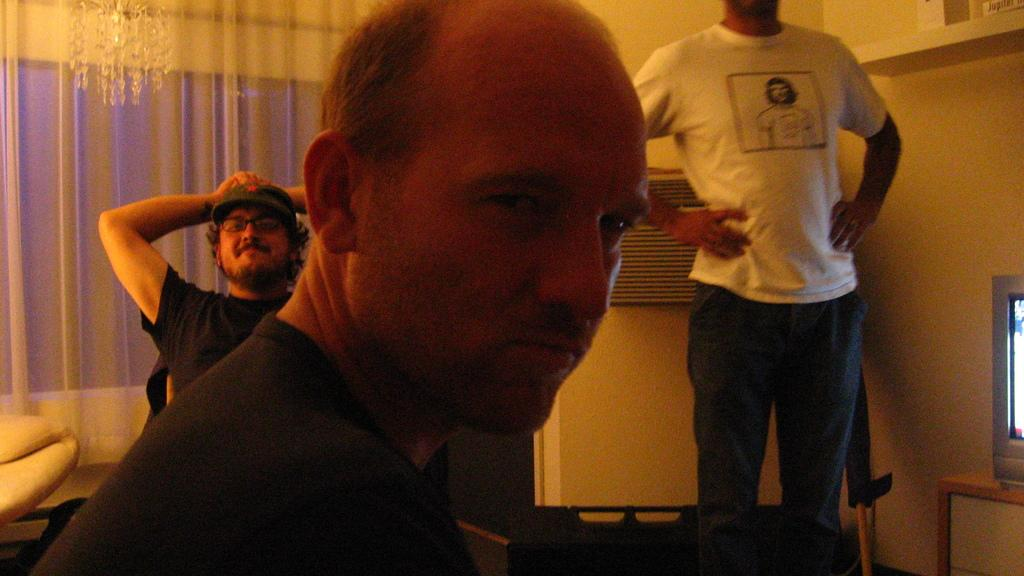How many people are present in the image? There are three people in the image. Can you describe the position of one of the individuals? A man is standing in the image. What object can be seen on a table in the image? There is a television on a table in the image. What type of window treatment is visible in the background? There are curtains in the background of the image. What type of architectural feature is visible in the background? There is a wall in the background of the image. What color are the father's toes in the image? There is no mention of a father or toes in the image, so this information cannot be provided. 